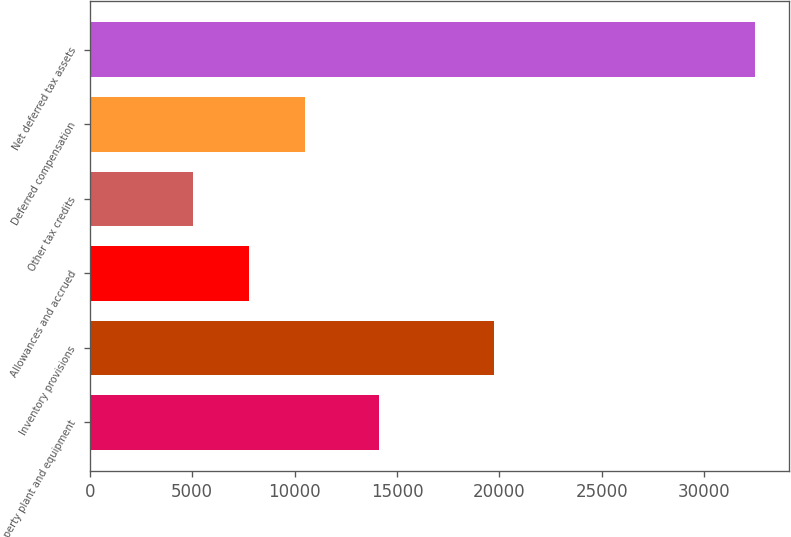Convert chart to OTSL. <chart><loc_0><loc_0><loc_500><loc_500><bar_chart><fcel>Property plant and equipment<fcel>Inventory provisions<fcel>Allowances and accrued<fcel>Other tax credits<fcel>Deferred compensation<fcel>Net deferred tax assets<nl><fcel>14122<fcel>19710<fcel>7773<fcel>5027<fcel>10519<fcel>32487<nl></chart> 